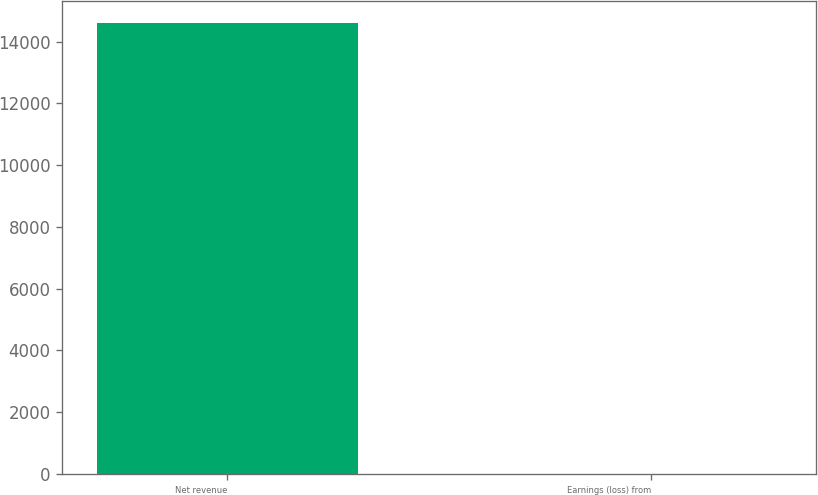<chart> <loc_0><loc_0><loc_500><loc_500><bar_chart><fcel>Net revenue<fcel>Earnings (loss) from<nl><fcel>14593<fcel>1<nl></chart> 